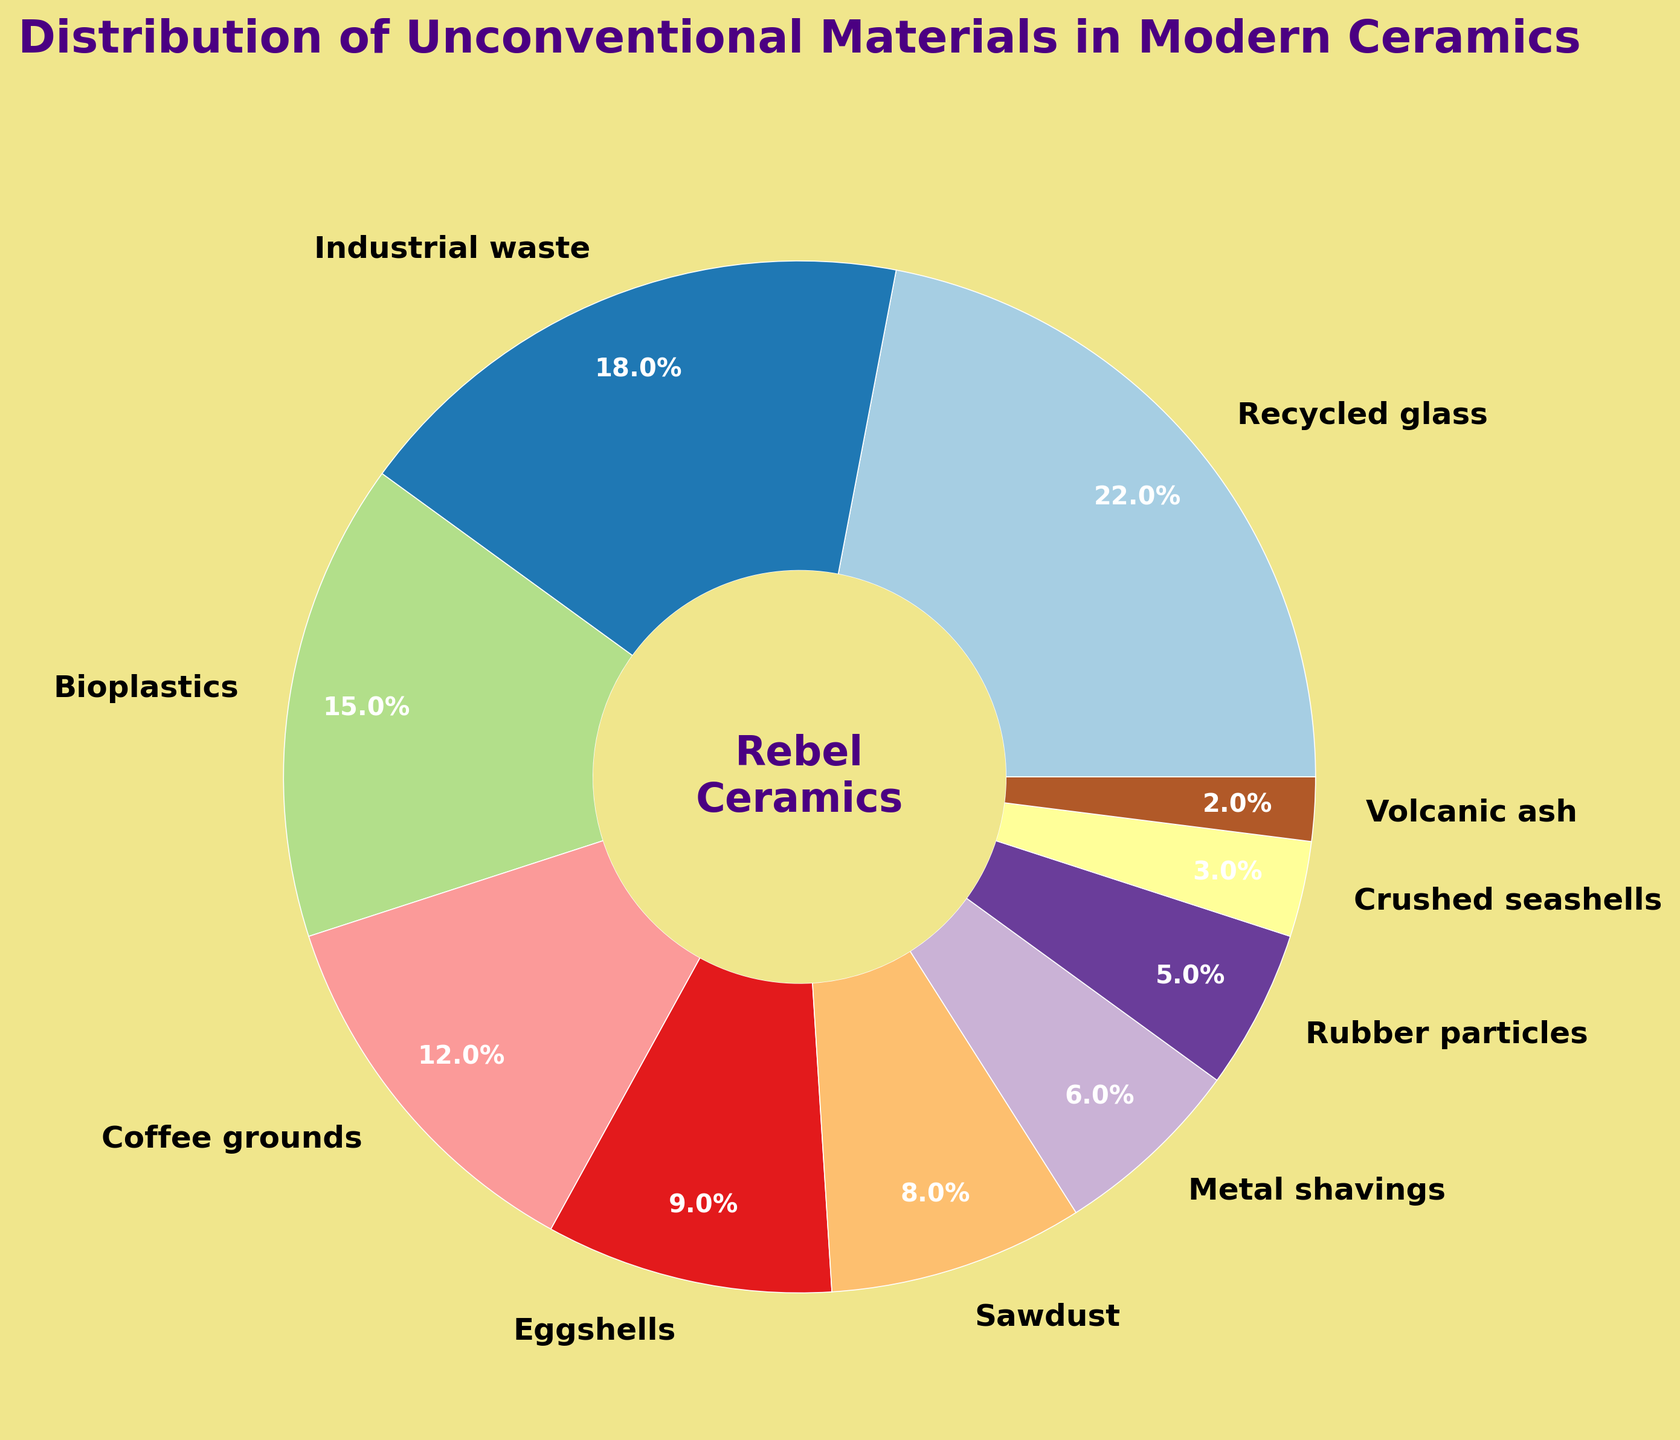What's the combined percentage of Recycled glass and Industrial waste in modern ceramics? To find the combined percentage, add the percentage of Recycled glass (22%) and the percentage of Industrial waste (18%). 22% + 18% = 40%.
Answer: 40% Which material has the smallest contribution in modern ceramics? The material with the smallest percentage is Volcanic ash, which contributes 2% to the overall distribution.
Answer: Volcanic ash How much more percentage of Recycled glass is used than Crushed seashells? Subtract the percentage of Crushed seashells (3%) from the percentage of Recycled glass (22%). 22% - 3% = 19%.
Answer: 19% What materials have a contribution percentage less than 10%? The materials with contributions less than 10% are Eggshells (9%), Sawdust (8%), Metal shavings (6%), Rubber particles (5%), Crushed seashells (3%), and Volcanic ash (2%).
Answer: Eggshells, Sawdust, Metal shavings, Rubber particles, Crushed seashells, Volcanic ash Which material has a higher contribution, Coffee grounds or Bioplastics? Comparing the percentages, Coffee grounds have 12% and Bioplastics have 15%. Bioplastics have a higher contribution.
Answer: Bioplastics Is the sum of percentages of Sawdust and Metal shavings greater than Bioplastics? Calculate the sum of Sawdust (8%) and Metal shavings (6%), which is 8% + 6% = 14%. Compare this with Bioplastics (15%). 14% is not greater than 15%.
Answer: No What is the color assigned to Coffee grounds in the pie chart? Visually identify the section labeled "Coffee grounds", which appears in a specific segment of the pie chart. The color assigned to this section can be described as distinct from the other segments.
Answer: Specific color for Coffee grounds Which two materials have the closest percentage values? The two materials closest in percentage values are Sawdust (8%) and Eggshells (9%), with a difference of 1%.
Answer: Sawdust and Eggshells What is the central text displayed within the pie chart's center circle? The text displayed in the center circle is "Rebel Ceramics" with proper formatting such as color, font weight, and size.
Answer: Rebel Ceramics What is the difference in percentage points between the highest and the lowest contributing materials? Subtract the percentage of the lowest contributing material, Volcanic ash (2%), from the highest contributing material, Recycled glass (22%). 22% - 2% = 20%.
Answer: 20% 